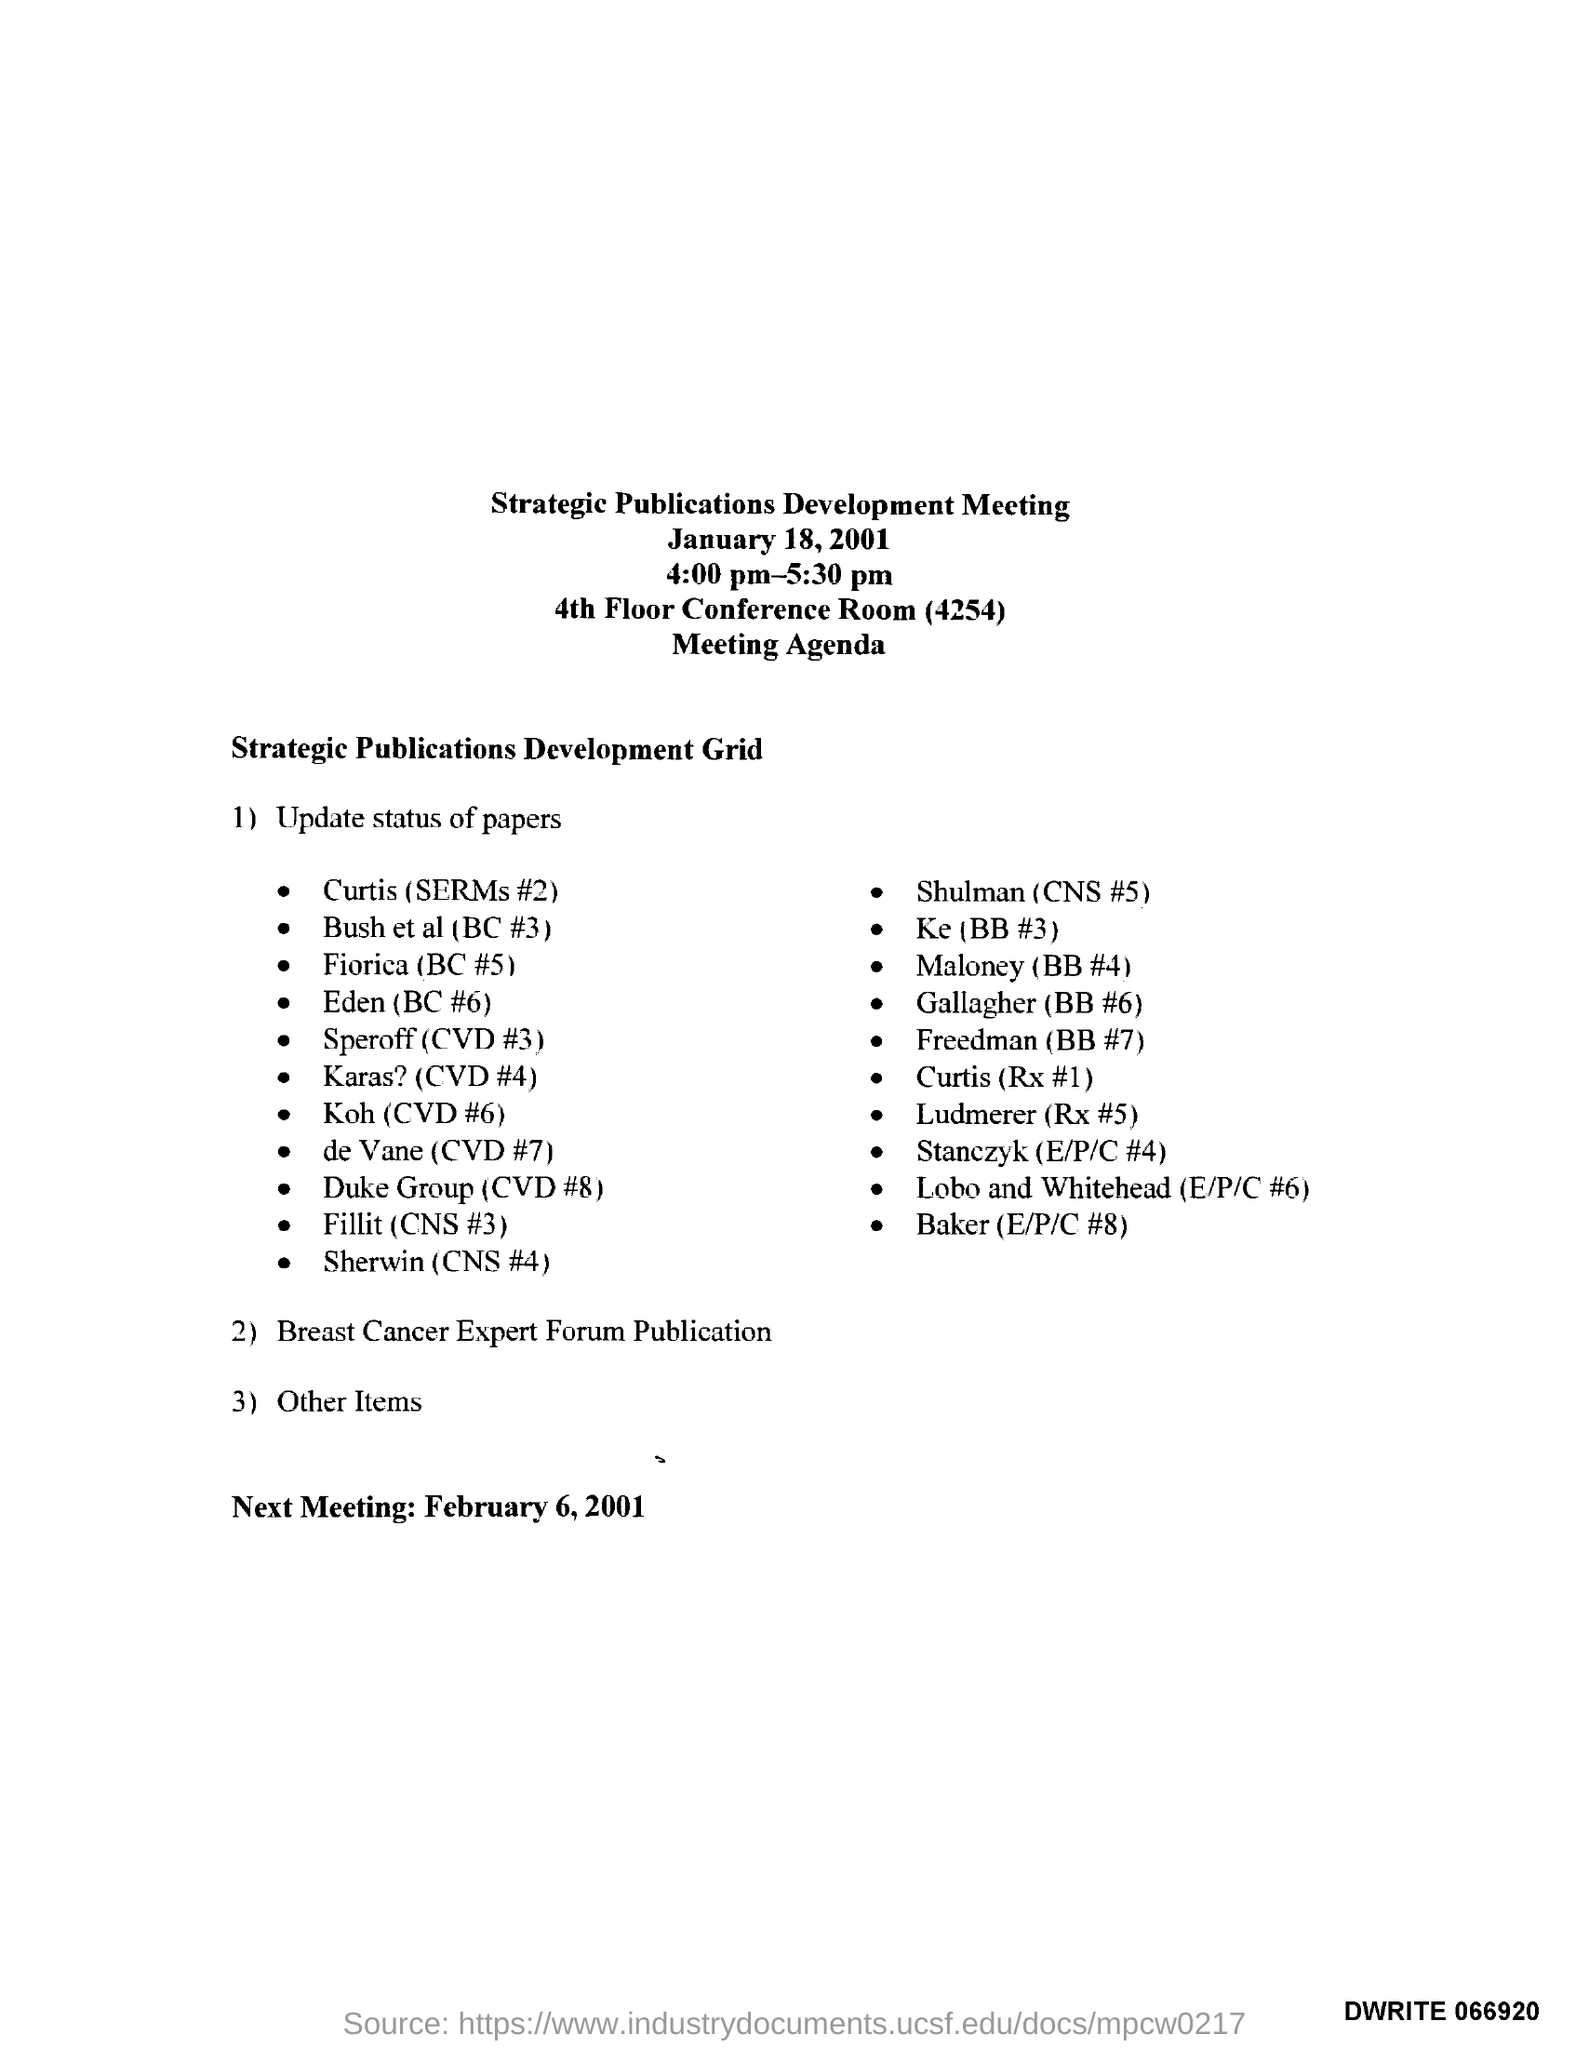When is the Strategic Publications Development Meeting held?
Keep it short and to the point. January 18, 2001. In which place, the Strategic Publications Development Meeting is organized?
Keep it short and to the point. 4th Floor Conference Room (4254). What time is the Strategic Publications Development Meeting scheduled?
Offer a terse response. 4:00 pm-5:30 pm. When is the next meeting scheduled as per the agenda?
Give a very brief answer. February 6, 2001. 